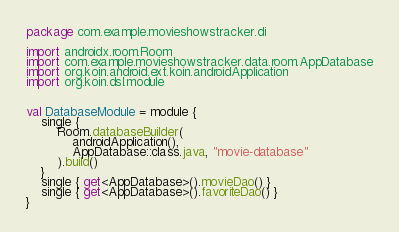Convert code to text. <code><loc_0><loc_0><loc_500><loc_500><_Kotlin_>package com.example.movieshowstracker.di

import androidx.room.Room
import com.example.movieshowstracker.data.room.AppDatabase
import org.koin.android.ext.koin.androidApplication
import org.koin.dsl.module


val DatabaseModule = module {
    single {
        Room.databaseBuilder(
            androidApplication(),
            AppDatabase::class.java, "movie-database"
        ).build()
    }
    single { get<AppDatabase>().movieDao() }
    single { get<AppDatabase>().favoriteDao() }
}</code> 